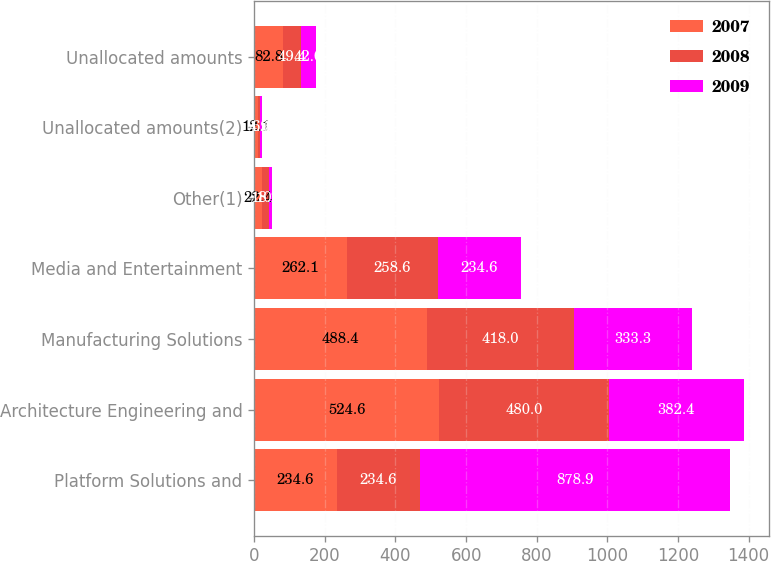Convert chart to OTSL. <chart><loc_0><loc_0><loc_500><loc_500><stacked_bar_chart><ecel><fcel>Platform Solutions and<fcel>Architecture Engineering and<fcel>Manufacturing Solutions<fcel>Media and Entertainment<fcel>Other(1)<fcel>Unallocated amounts(2)<fcel>Unallocated amounts<nl><fcel>2007<fcel>234.6<fcel>524.6<fcel>488.4<fcel>262.1<fcel>22.4<fcel>12.1<fcel>82.8<nl><fcel>2008<fcel>234.6<fcel>480<fcel>418<fcel>258.6<fcel>18.2<fcel>4.9<fcel>49.4<nl><fcel>2009<fcel>878.9<fcel>382.4<fcel>333.3<fcel>234.6<fcel>10.6<fcel>6.1<fcel>42<nl></chart> 